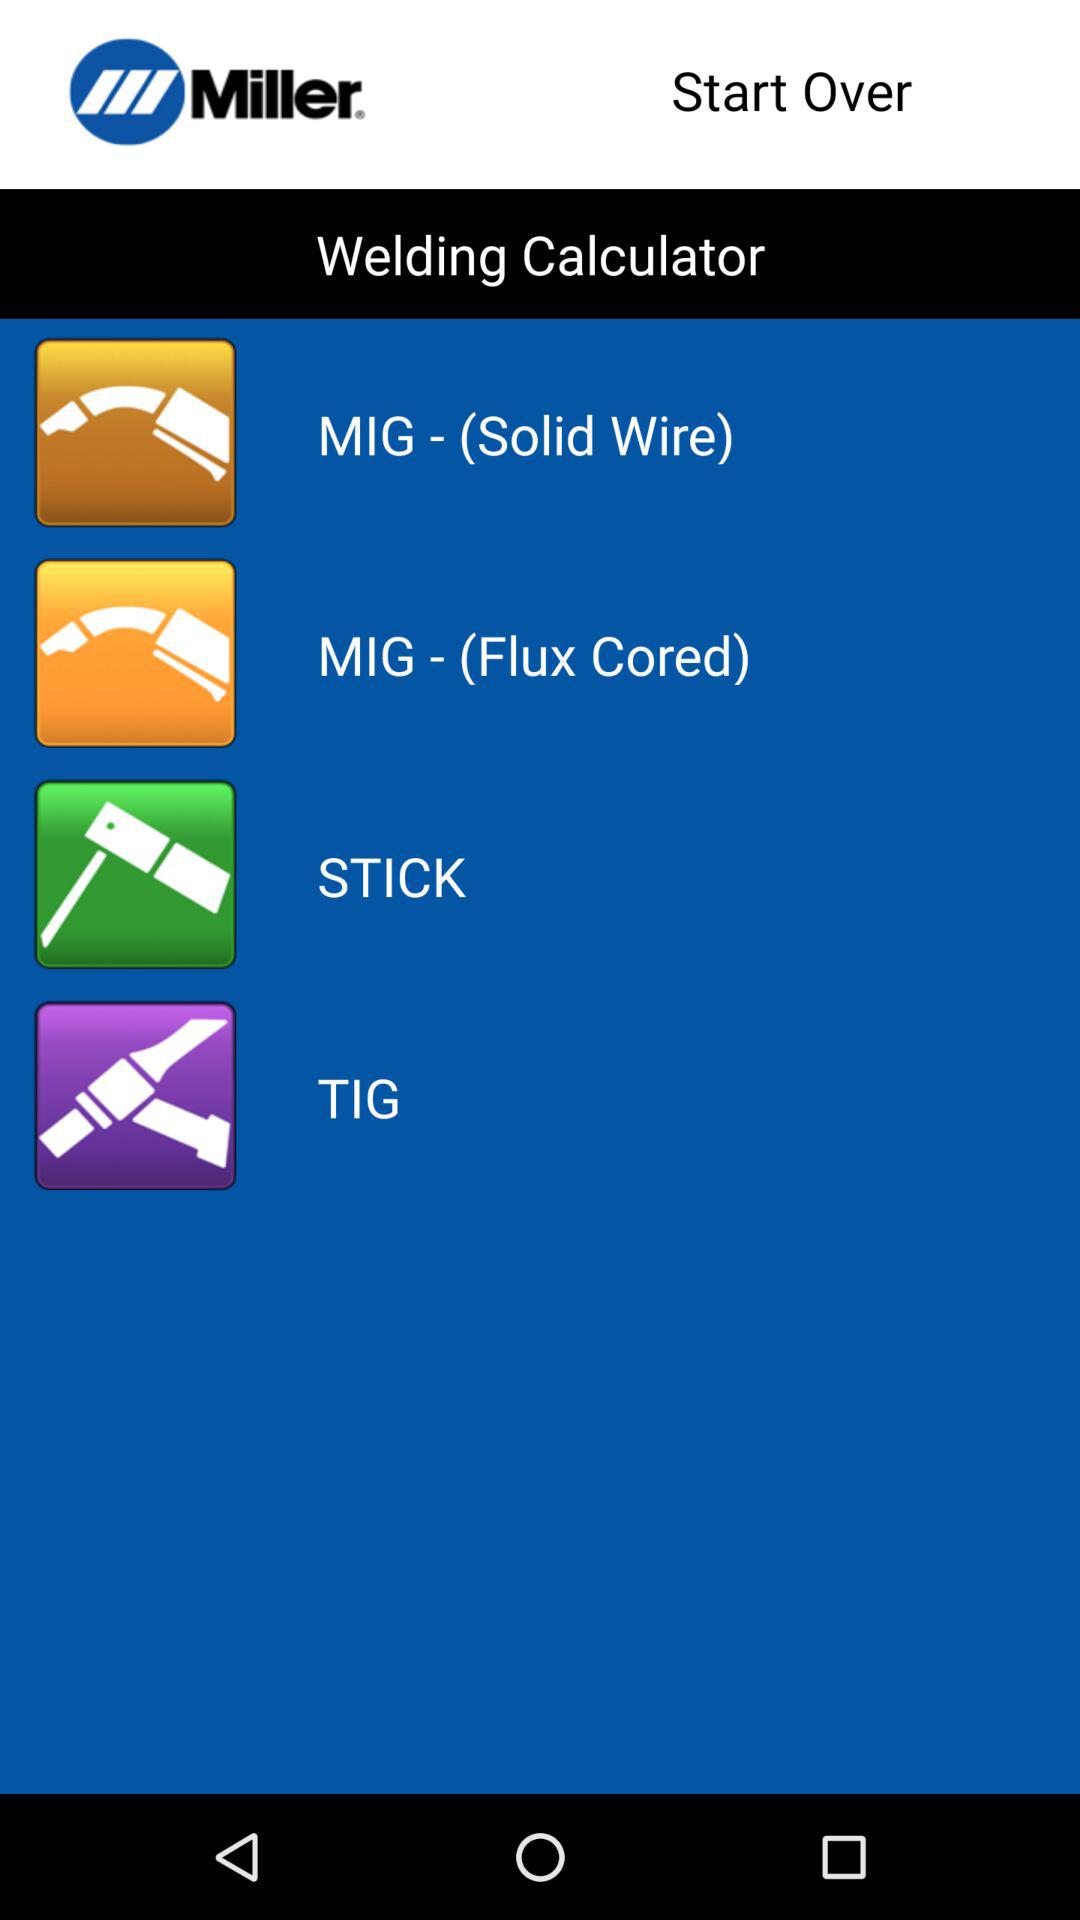Which application version is being used?
When the provided information is insufficient, respond with <no answer>. <no answer> 